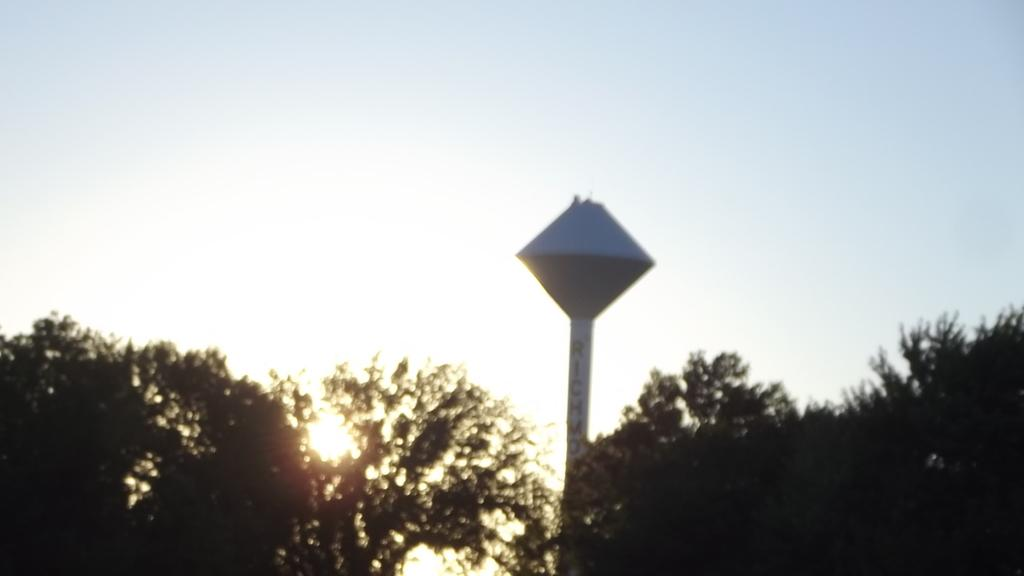What is the main object in the image? There is a pole in the image. What other natural elements can be seen in the image? There are trees in the image. What is visible in the background of the image? The sky is visible in the background of the image. What question is being asked by the person holding the rifle in the image? There is no person holding a rifle in the image, and therefore no question being asked. 